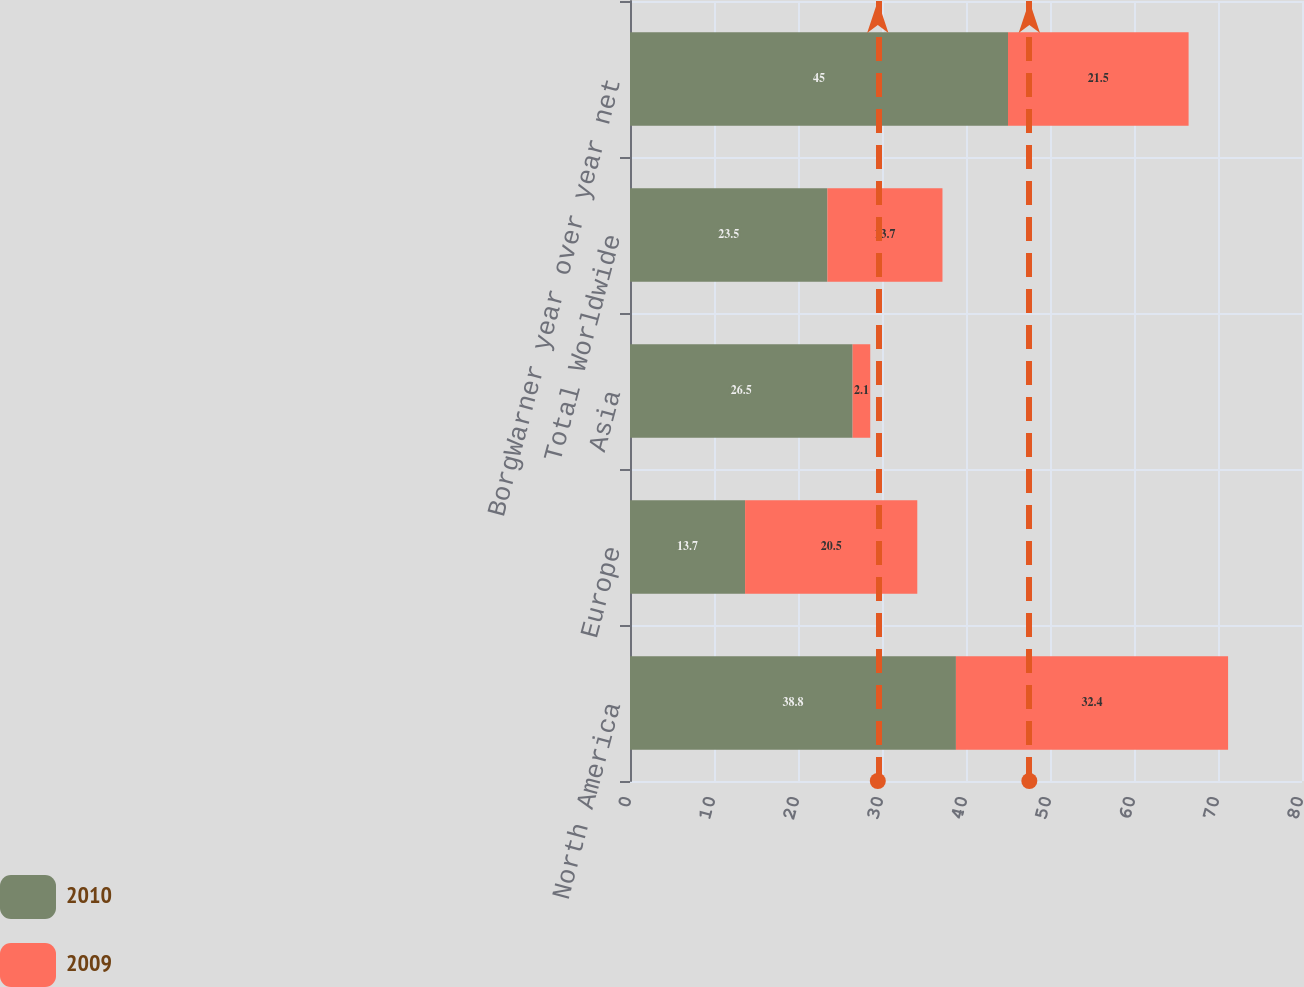Convert chart to OTSL. <chart><loc_0><loc_0><loc_500><loc_500><stacked_bar_chart><ecel><fcel>North America<fcel>Europe<fcel>Asia<fcel>Total Worldwide<fcel>BorgWarner year over year net<nl><fcel>2010<fcel>38.8<fcel>13.7<fcel>26.5<fcel>23.5<fcel>45<nl><fcel>2009<fcel>32.4<fcel>20.5<fcel>2.1<fcel>13.7<fcel>21.5<nl></chart> 